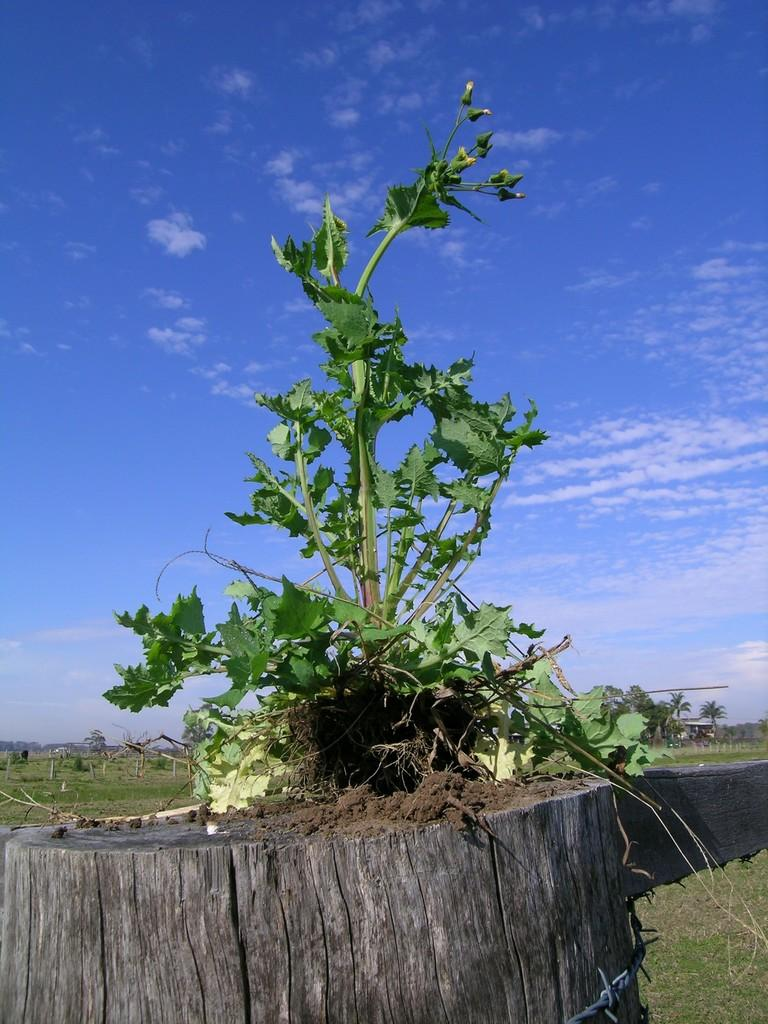What type of vegetation can be seen in the image? There is grass, a log, a plant, and trees visible in the image. What is the natural setting in the image? The natural setting includes grass, trees, and the sky visible in the background. What can be seen in the sky in the image? There are clouds in the sky in the image. What health advice is being given in the image? There is no health advice present in the image. What verse is being recited in the image? There is no verse or recitation present in the image. 